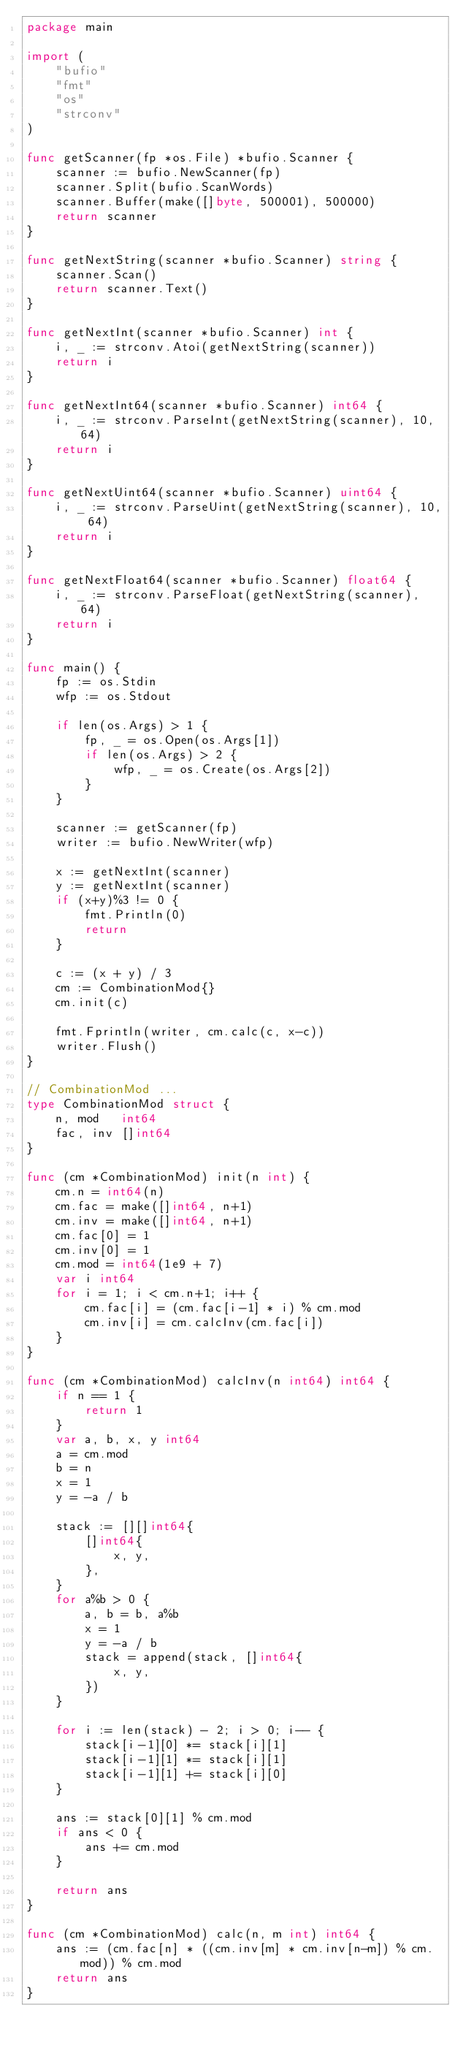Convert code to text. <code><loc_0><loc_0><loc_500><loc_500><_Go_>package main

import (
	"bufio"
	"fmt"
	"os"
	"strconv"
)

func getScanner(fp *os.File) *bufio.Scanner {
	scanner := bufio.NewScanner(fp)
	scanner.Split(bufio.ScanWords)
	scanner.Buffer(make([]byte, 500001), 500000)
	return scanner
}

func getNextString(scanner *bufio.Scanner) string {
	scanner.Scan()
	return scanner.Text()
}

func getNextInt(scanner *bufio.Scanner) int {
	i, _ := strconv.Atoi(getNextString(scanner))
	return i
}

func getNextInt64(scanner *bufio.Scanner) int64 {
	i, _ := strconv.ParseInt(getNextString(scanner), 10, 64)
	return i
}

func getNextUint64(scanner *bufio.Scanner) uint64 {
	i, _ := strconv.ParseUint(getNextString(scanner), 10, 64)
	return i
}

func getNextFloat64(scanner *bufio.Scanner) float64 {
	i, _ := strconv.ParseFloat(getNextString(scanner), 64)
	return i
}

func main() {
	fp := os.Stdin
	wfp := os.Stdout

	if len(os.Args) > 1 {
		fp, _ = os.Open(os.Args[1])
		if len(os.Args) > 2 {
			wfp, _ = os.Create(os.Args[2])
		}
	}

	scanner := getScanner(fp)
	writer := bufio.NewWriter(wfp)

	x := getNextInt(scanner)
	y := getNextInt(scanner)
	if (x+y)%3 != 0 {
		fmt.Println(0)
		return
	}

	c := (x + y) / 3
	cm := CombinationMod{}
	cm.init(c)

	fmt.Fprintln(writer, cm.calc(c, x-c))
	writer.Flush()
}

// CombinationMod ...
type CombinationMod struct {
	n, mod   int64
	fac, inv []int64
}

func (cm *CombinationMod) init(n int) {
	cm.n = int64(n)
	cm.fac = make([]int64, n+1)
	cm.inv = make([]int64, n+1)
	cm.fac[0] = 1
	cm.inv[0] = 1
	cm.mod = int64(1e9 + 7)
	var i int64
	for i = 1; i < cm.n+1; i++ {
		cm.fac[i] = (cm.fac[i-1] * i) % cm.mod
		cm.inv[i] = cm.calcInv(cm.fac[i])
	}
}

func (cm *CombinationMod) calcInv(n int64) int64 {
	if n == 1 {
		return 1
	}
	var a, b, x, y int64
	a = cm.mod
	b = n
	x = 1
	y = -a / b

	stack := [][]int64{
		[]int64{
			x, y,
		},
	}
	for a%b > 0 {
		a, b = b, a%b
		x = 1
		y = -a / b
		stack = append(stack, []int64{
			x, y,
		})
	}

	for i := len(stack) - 2; i > 0; i-- {
		stack[i-1][0] *= stack[i][1]
		stack[i-1][1] *= stack[i][1]
		stack[i-1][1] += stack[i][0]
	}

	ans := stack[0][1] % cm.mod
	if ans < 0 {
		ans += cm.mod
	}

	return ans
}

func (cm *CombinationMod) calc(n, m int) int64 {
	ans := (cm.fac[n] * ((cm.inv[m] * cm.inv[n-m]) % cm.mod)) % cm.mod
	return ans
}
</code> 